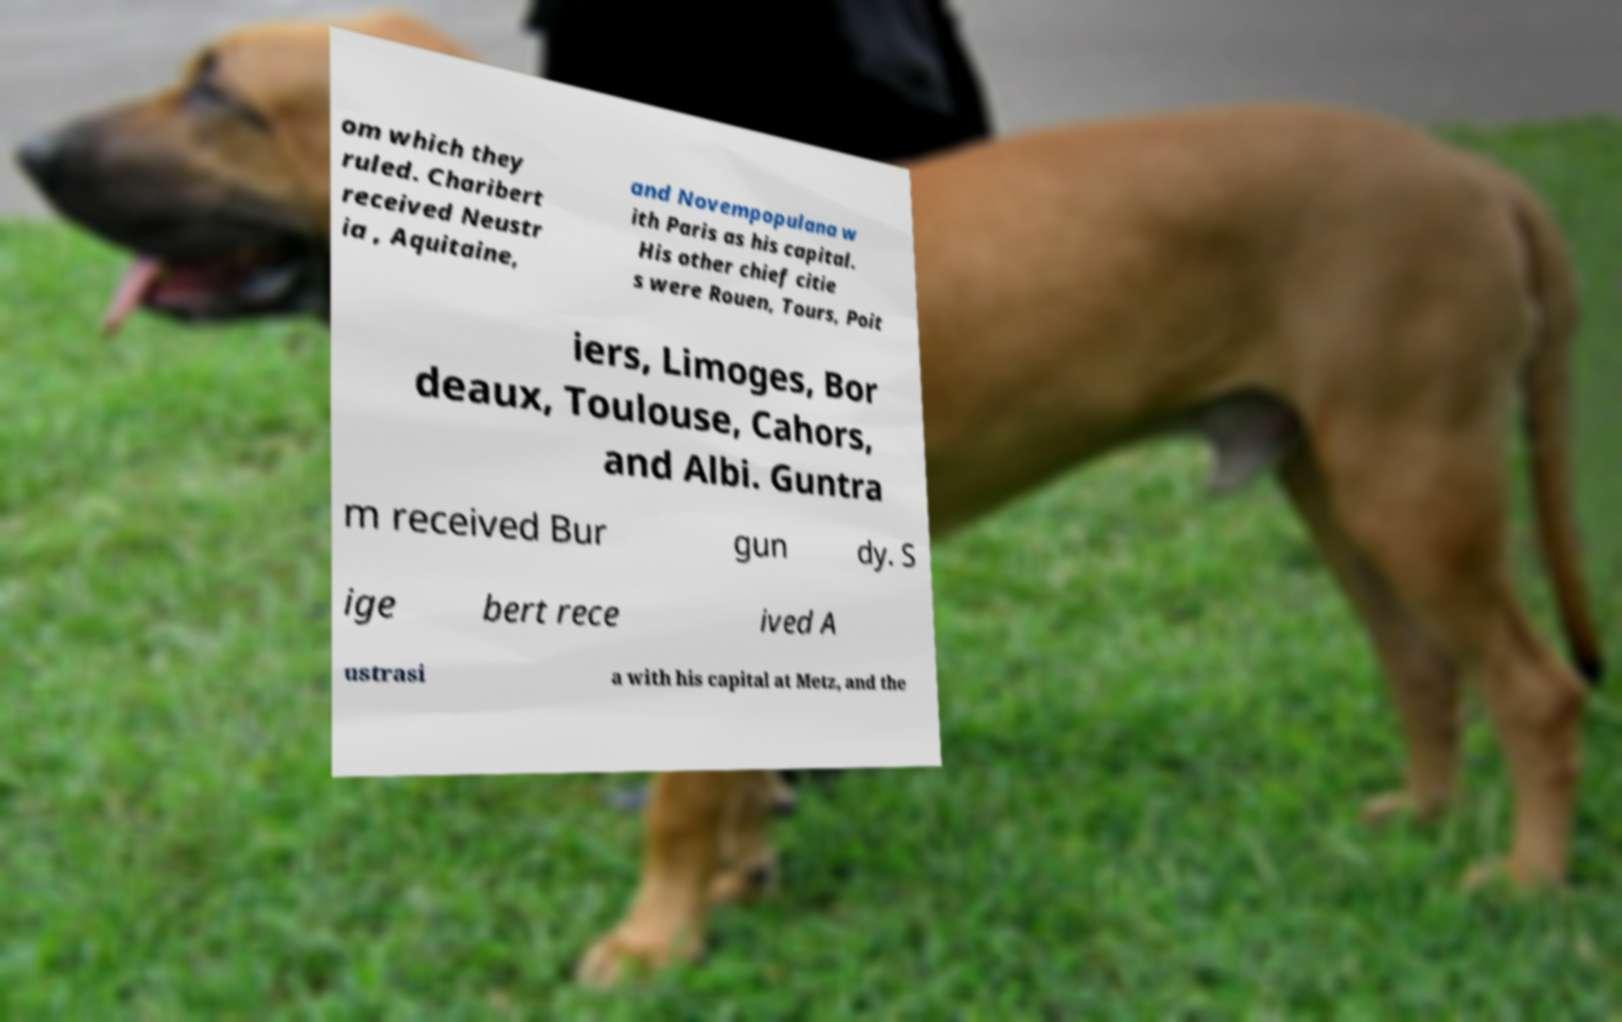For documentation purposes, I need the text within this image transcribed. Could you provide that? om which they ruled. Charibert received Neustr ia , Aquitaine, and Novempopulana w ith Paris as his capital. His other chief citie s were Rouen, Tours, Poit iers, Limoges, Bor deaux, Toulouse, Cahors, and Albi. Guntra m received Bur gun dy. S ige bert rece ived A ustrasi a with his capital at Metz, and the 